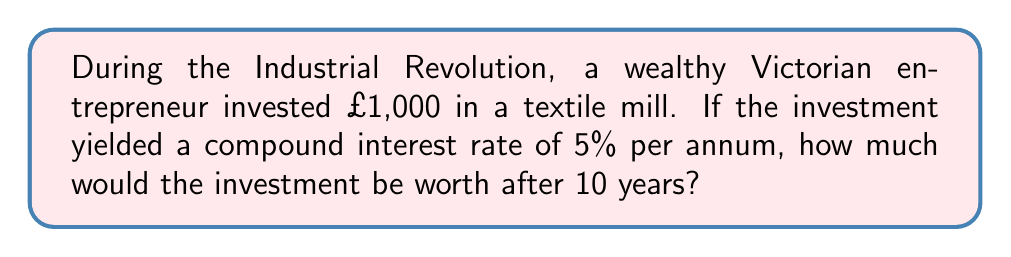Could you help me with this problem? To solve this problem, we'll use the compound interest formula:

$$A = P(1 + r)^n$$

Where:
$A$ = Final amount
$P$ = Principal (initial investment)
$r$ = Annual interest rate (as a decimal)
$n$ = Number of years

Given:
$P = £1,000$
$r = 5\% = 0.05$
$n = 10$ years

Let's substitute these values into the formula:

$$A = 1000(1 + 0.05)^{10}$$

Now, let's calculate step by step:

1) First, calculate $(1 + 0.05)$:
   $1 + 0.05 = 1.05$

2) Now, raise 1.05 to the power of 10:
   $1.05^{10} \approx 1.6288946$

3) Finally, multiply this by the principal:
   $1000 \times 1.6288946 \approx 1628.89$

Therefore, after 10 years, the investment would be worth approximately £1,628.89.
Answer: £1,628.89 